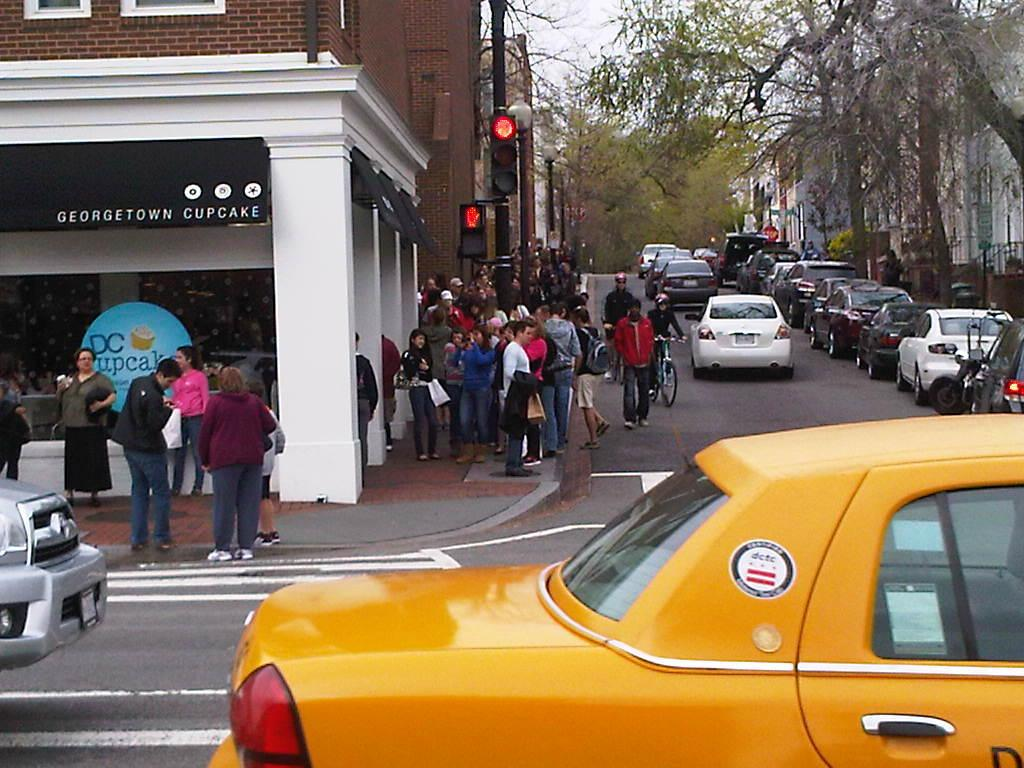<image>
Give a short and clear explanation of the subsequent image. A yellow cab glides by a Georgetown cupcake store  and fairly busy 